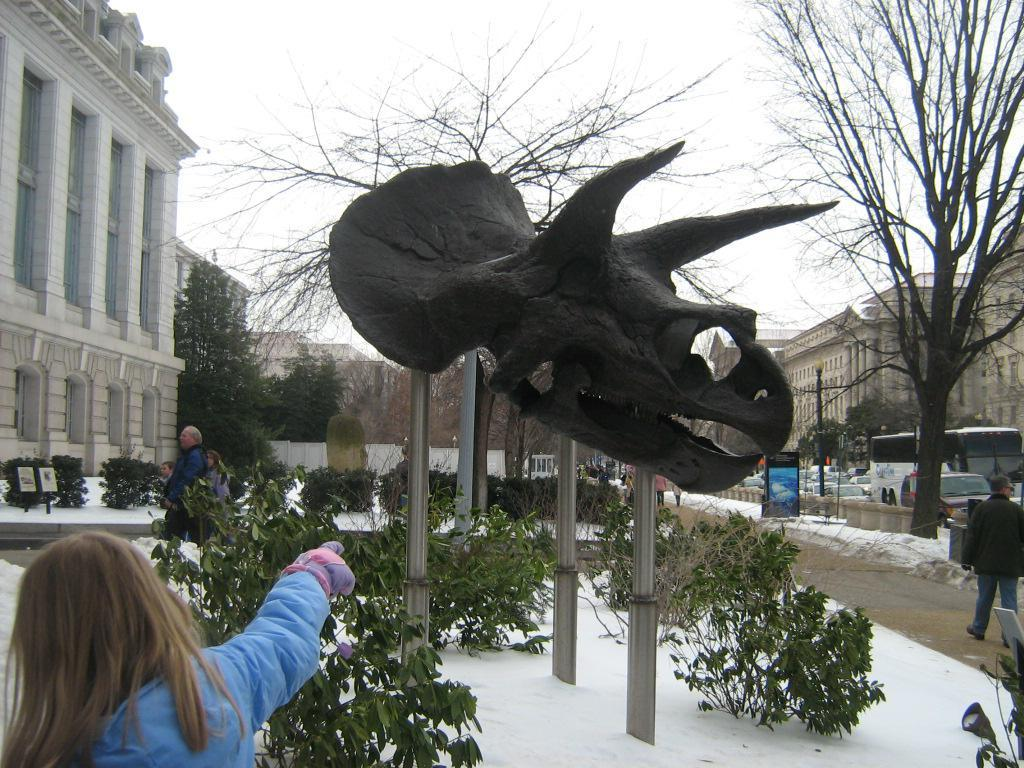What is the main subject in the middle of the image? There is a sculpture of an animal in the middle of the image. Who or what is located at the bottom of the image? There is a person at the bottom of the image. What type of vegetation can be seen in the image? There are plants and trees in the image. What type of structure is visible on the right side of the image? There is a building on the right side of the image. What type of instrument is being played by the cloud in the image? There is no cloud or instrument present in the image. 